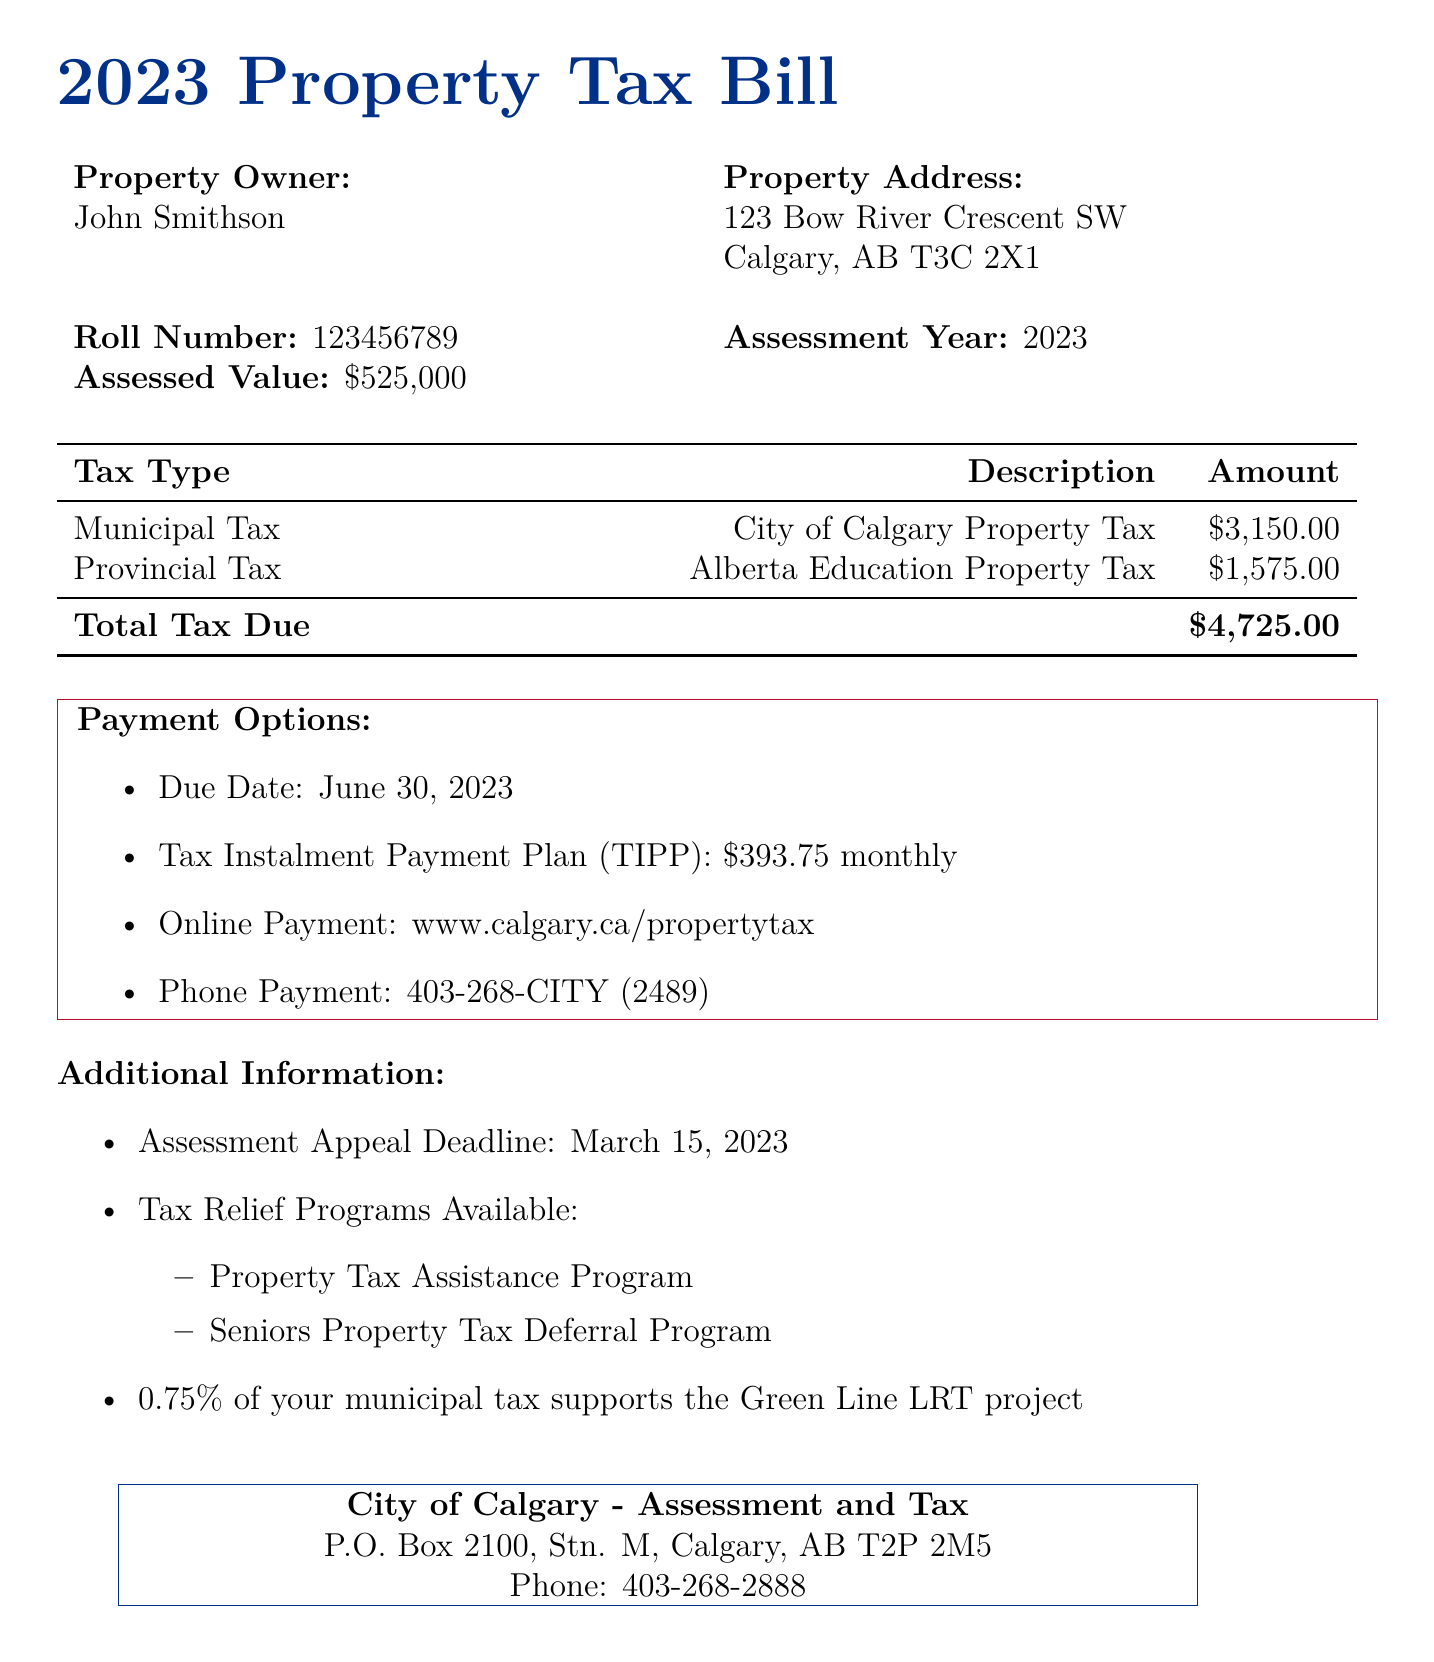What is the assessed value of the property? The assessed value is specified in the document under "Assessed Value," which states the value as $525,000.
Answer: $525,000 Who is the property owner? The property owner is mentioned at the top of the document in the property owner section.
Answer: John Smithson What is the due date for the property tax payment? The due date is listed in the payment options section of the document.
Answer: June 30, 2023 What is the total tax due? The total tax due is calculated from the municipal and provincial taxes, which is shown at the bottom of the tax table.
Answer: $4,725.00 How much is the municipal tax? The municipal tax amount is listed separately in the tax table of the document.
Answer: $3,150.00 What percentage of the municipal tax supports the Green Line LRT project? The percentage is stated in the additional information section regarding support for the Green Line LRT project.
Answer: 0.75% What programs are available for tax relief? The document mentions specific tax relief programs in the additional information section.
Answer: Property Tax Assistance Program, Seniors Property Tax Deferral Program What is the monthly payment amount under TIPP? The amount for the Tax Instalment Payment Plan (TIPP) is presented in the payment options section.
Answer: $393.75 